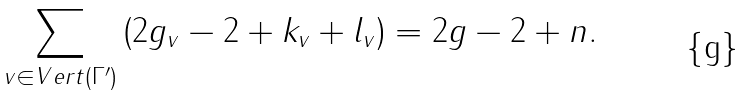Convert formula to latex. <formula><loc_0><loc_0><loc_500><loc_500>\sum _ { v \in V e r t ( \Gamma ^ { \prime } ) } \left ( 2 g _ { v } - 2 + k _ { v } + l _ { v } \right ) = 2 g - 2 + n .</formula> 